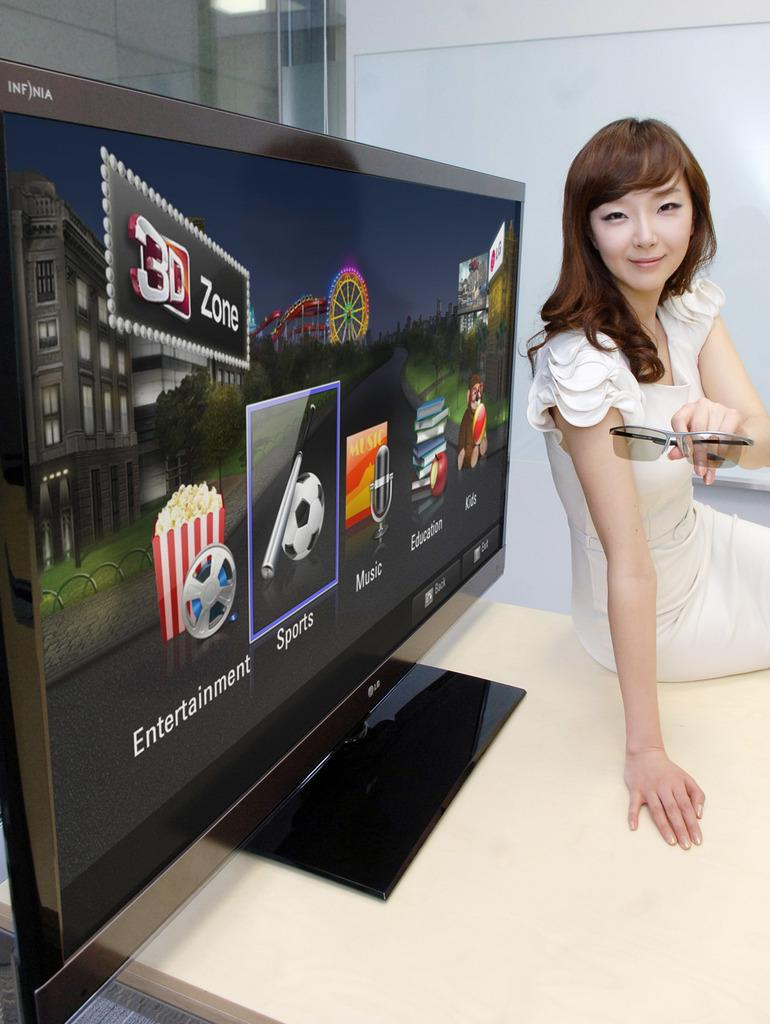<image>
Summarize the visual content of the image. A woman is displaying a TV that has entertainment, sports, and music on it. 